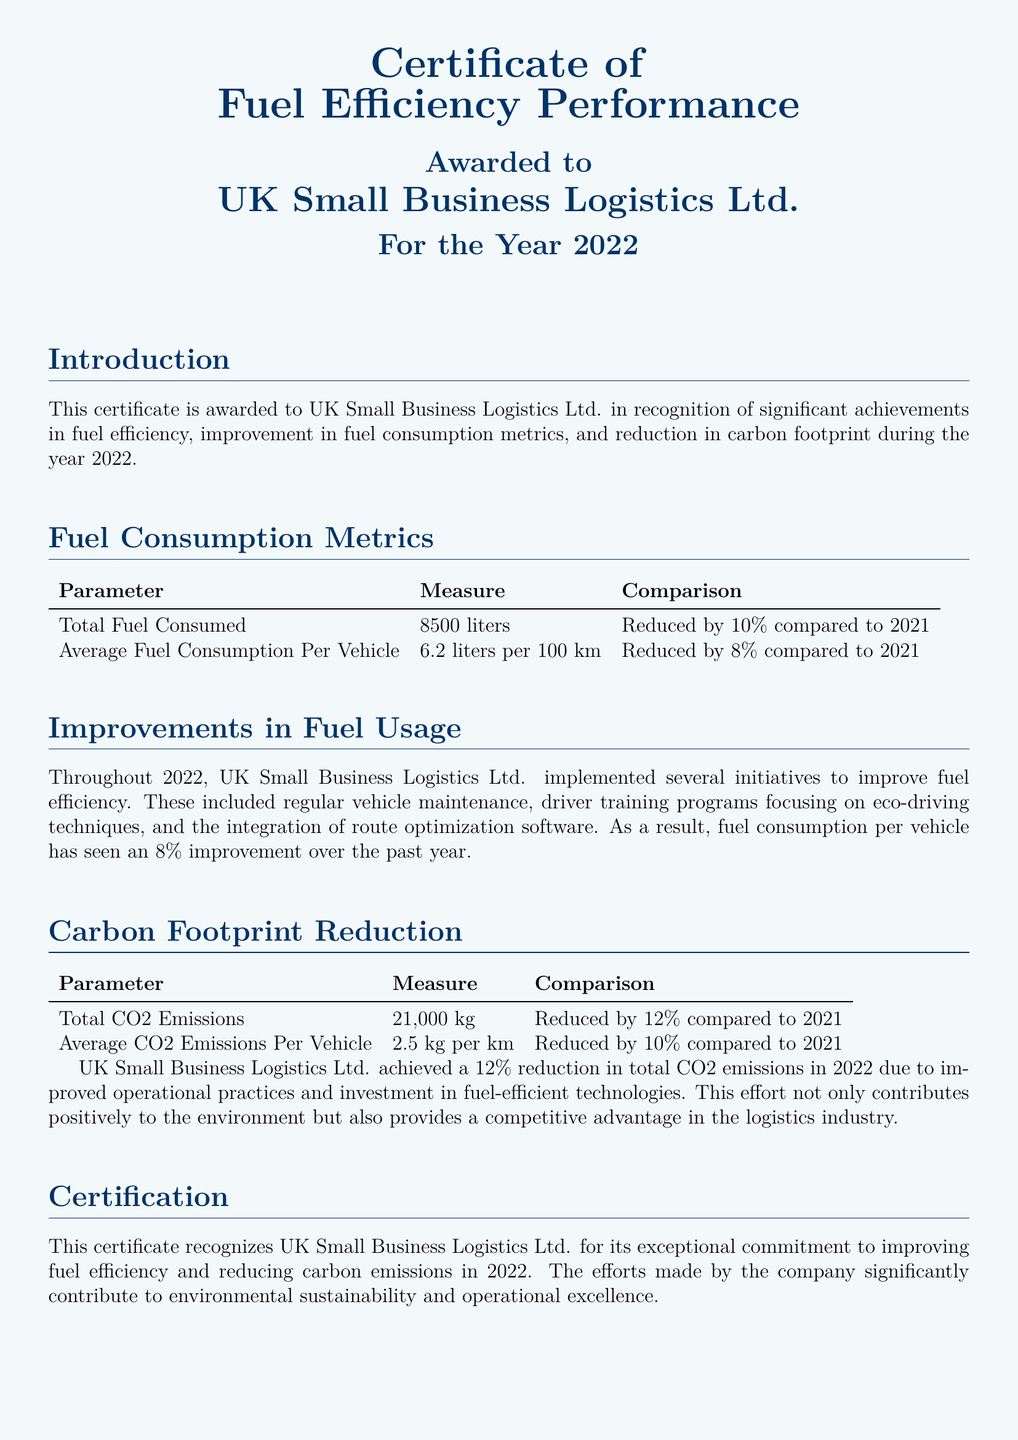what is the total fuel consumed? The total fuel consumed is specified as 8500 liters in the document.
Answer: 8500 liters what is the reduction percentage of average fuel consumption per vehicle? The document states that the average fuel consumption per vehicle was reduced by 8% compared to 2021.
Answer: 8% what is the total CO2 emissions for the year 2022? The total CO2 emissions recorded in the document is 21,000 kg for the year 2022.
Answer: 21,000 kg who is the certificate awarded to? The company recognized in the certificate is UK Small Business Logistics Ltd.
Answer: UK Small Business Logistics Ltd what year does the certificate pertain to? The certificate specifically mentions the year 2022 as the focus of the performance metrics.
Answer: 2022 what was the improvement in total fuel consumption compared to the previous year? The total fuel consumption was reduced by 10% compared to 2021, as per the document.
Answer: 10% what initiatives were implemented to improve fuel efficiency? The document highlights vehicle maintenance, driver training, and route optimization software as initiatives taken.
Answer: Regular vehicle maintenance, driver training programs, route optimization software what is the average CO2 emissions per vehicle? The average CO2 emissions per vehicle are specified in the document as 2.5 kg per km.
Answer: 2.5 kg per km how much was the total reduction in CO2 emissions? The total reduction in CO2 emissions is stated as 12% compared to the previous year.
Answer: 12% 